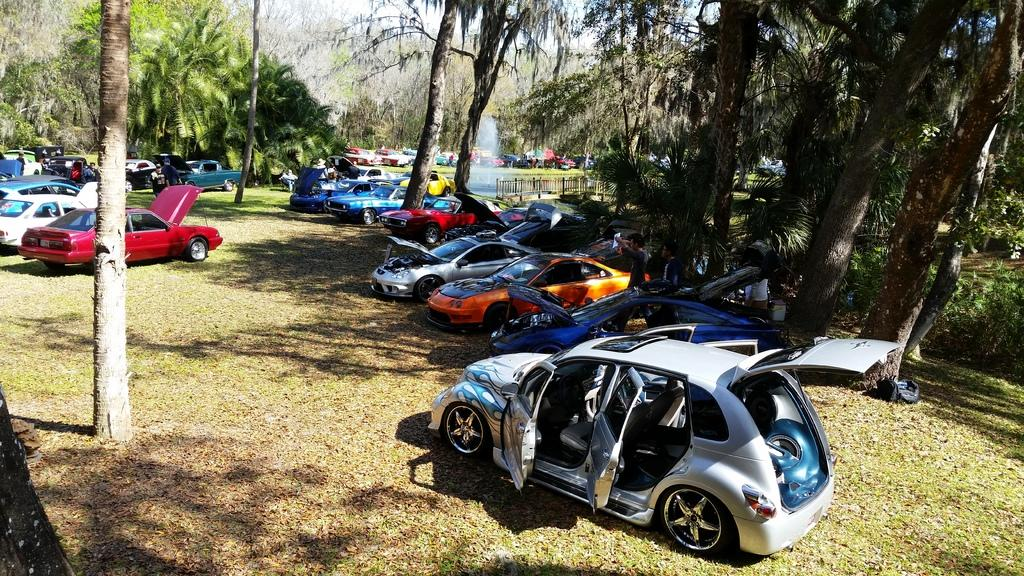What types of vehicles are present in the image? There are cars with different colors in the image. What is the status of the cars in the image? The cars are parked. What natural elements can be seen in the image? There are trees in the image. What is visible in the background of the image? The sky is visible in the background of the image. What type of produce is being harvested in the image? There is no produce or harvesting activity present in the image; it features parked cars and trees. What emotion can be seen on the cars' faces in the image? Cars do not have faces or emotions, so this question cannot be answered. 